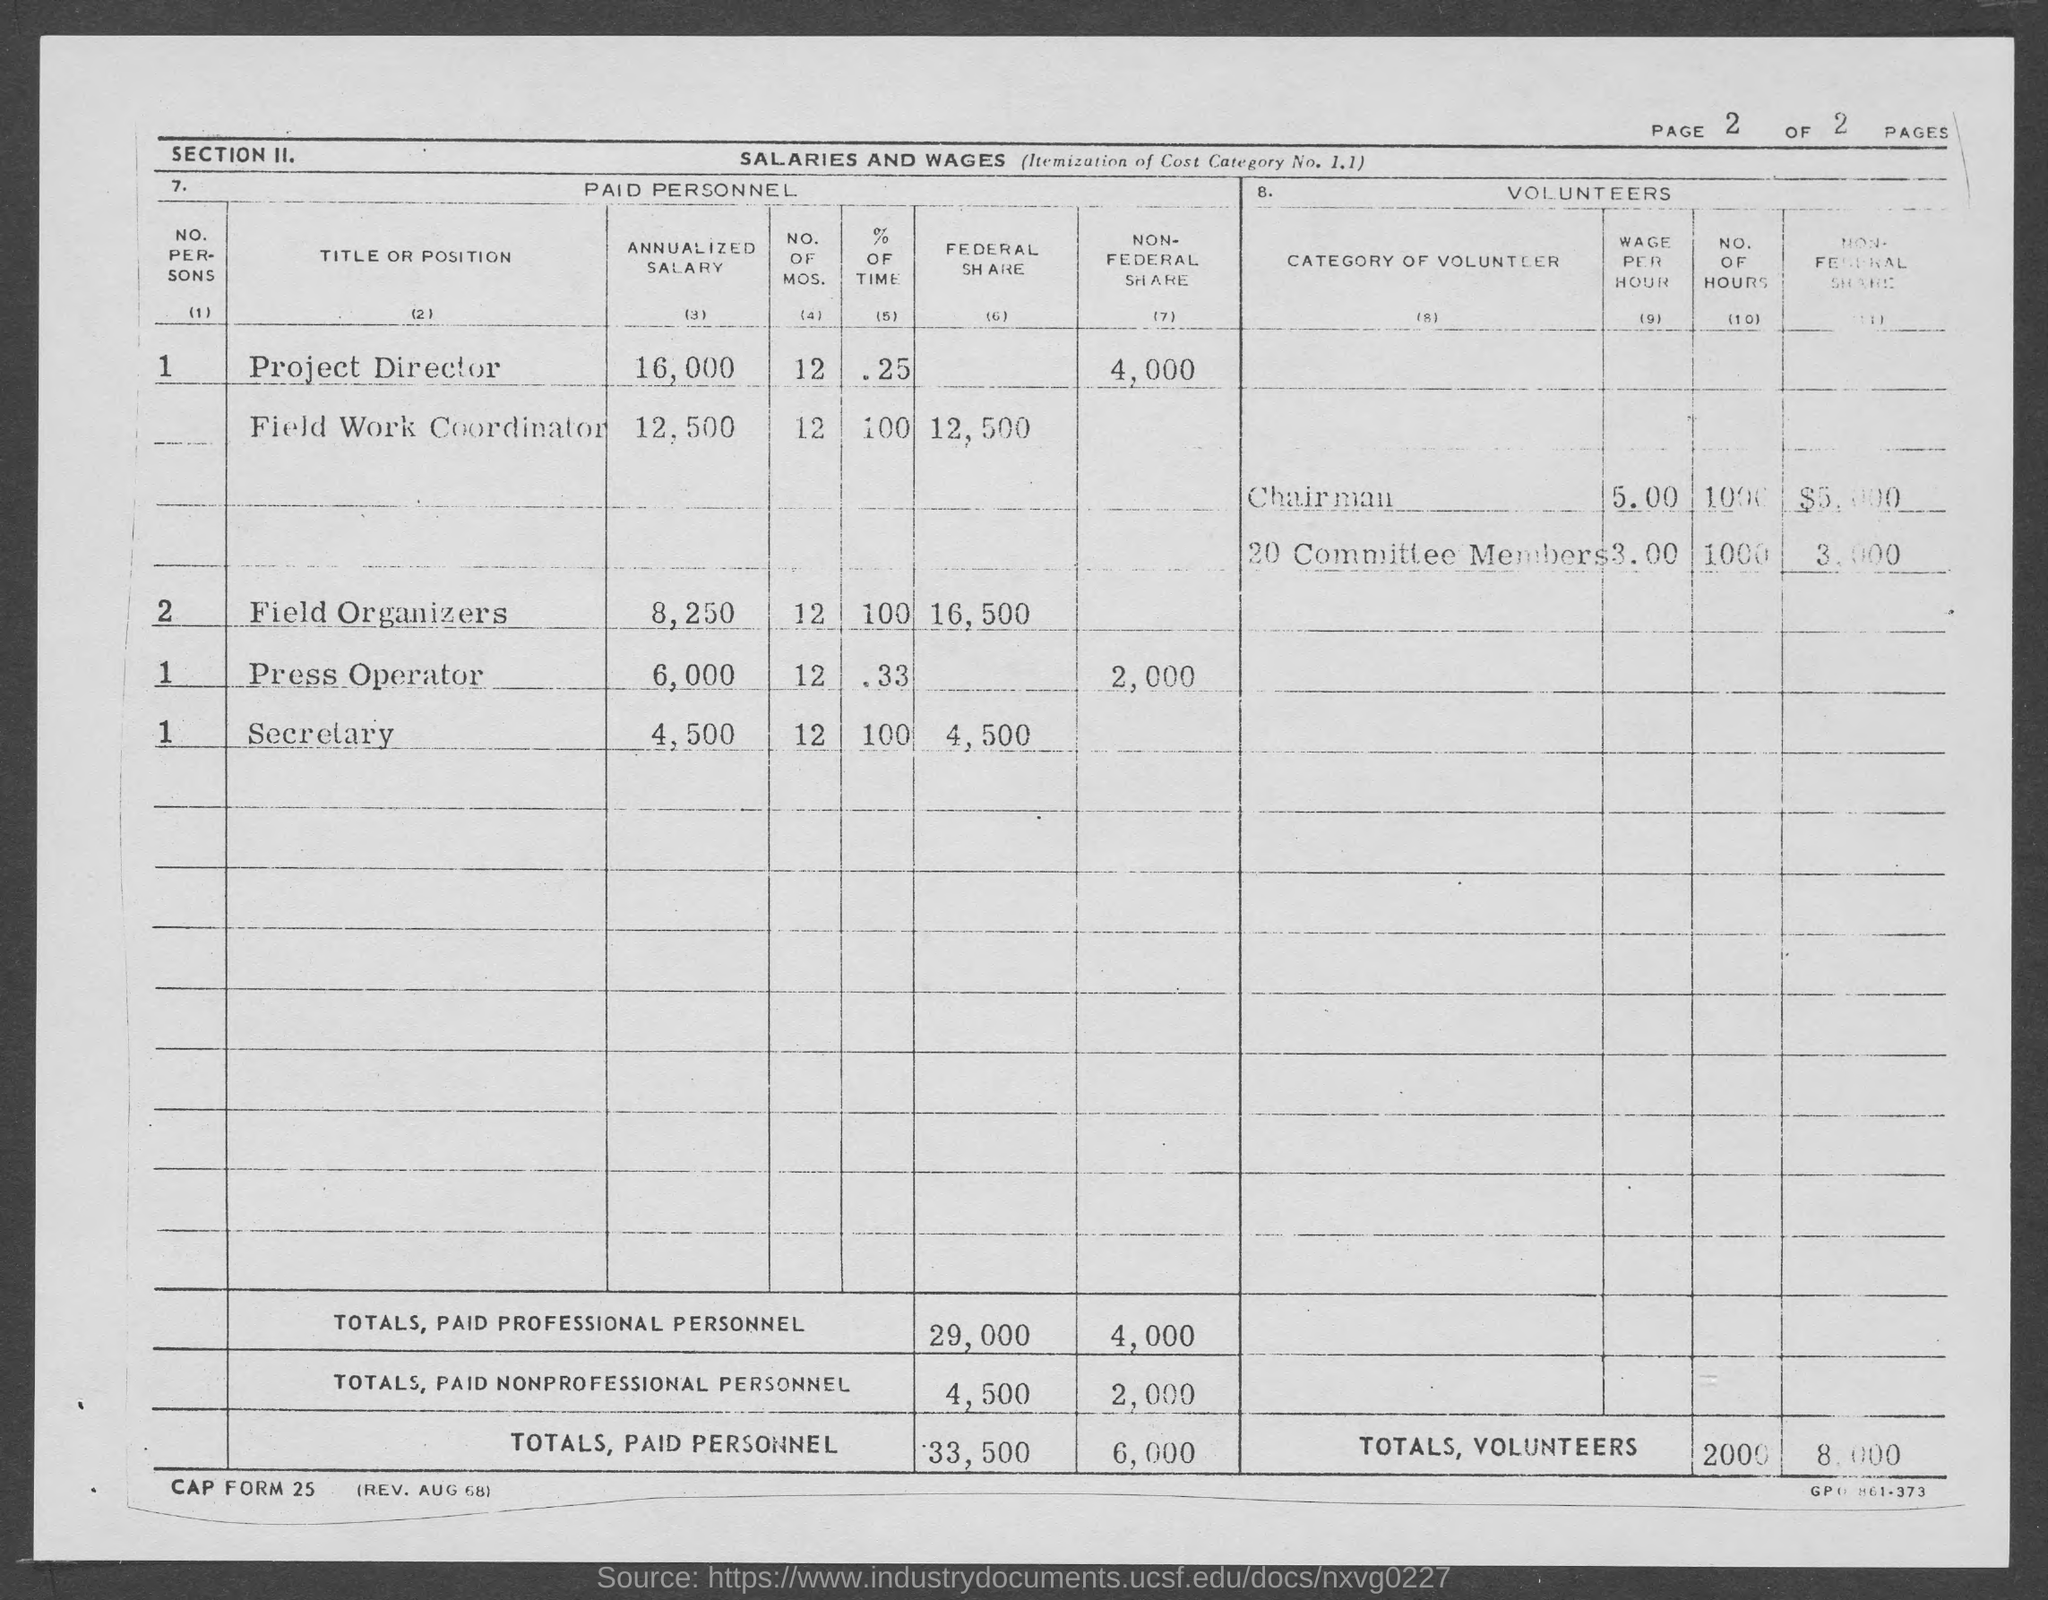What is the annualized salary of project director ?
Keep it short and to the point. $16,000. What is the annualized salary of field work coordinator ?
Offer a terse response. $12,500. What is the annualized salary of field organizers ?
Provide a succinct answer. $8,250. What is the annualized salary of press operator?
Ensure brevity in your answer.  $6,000. What is the annualized salary of secretary ?
Provide a succinct answer. 4,500. What is the federal share in totals, paid personnel ?
Your answer should be compact. 33,500. What is the non-federal share in totals, paid personnel ?
Ensure brevity in your answer.  6,000. 